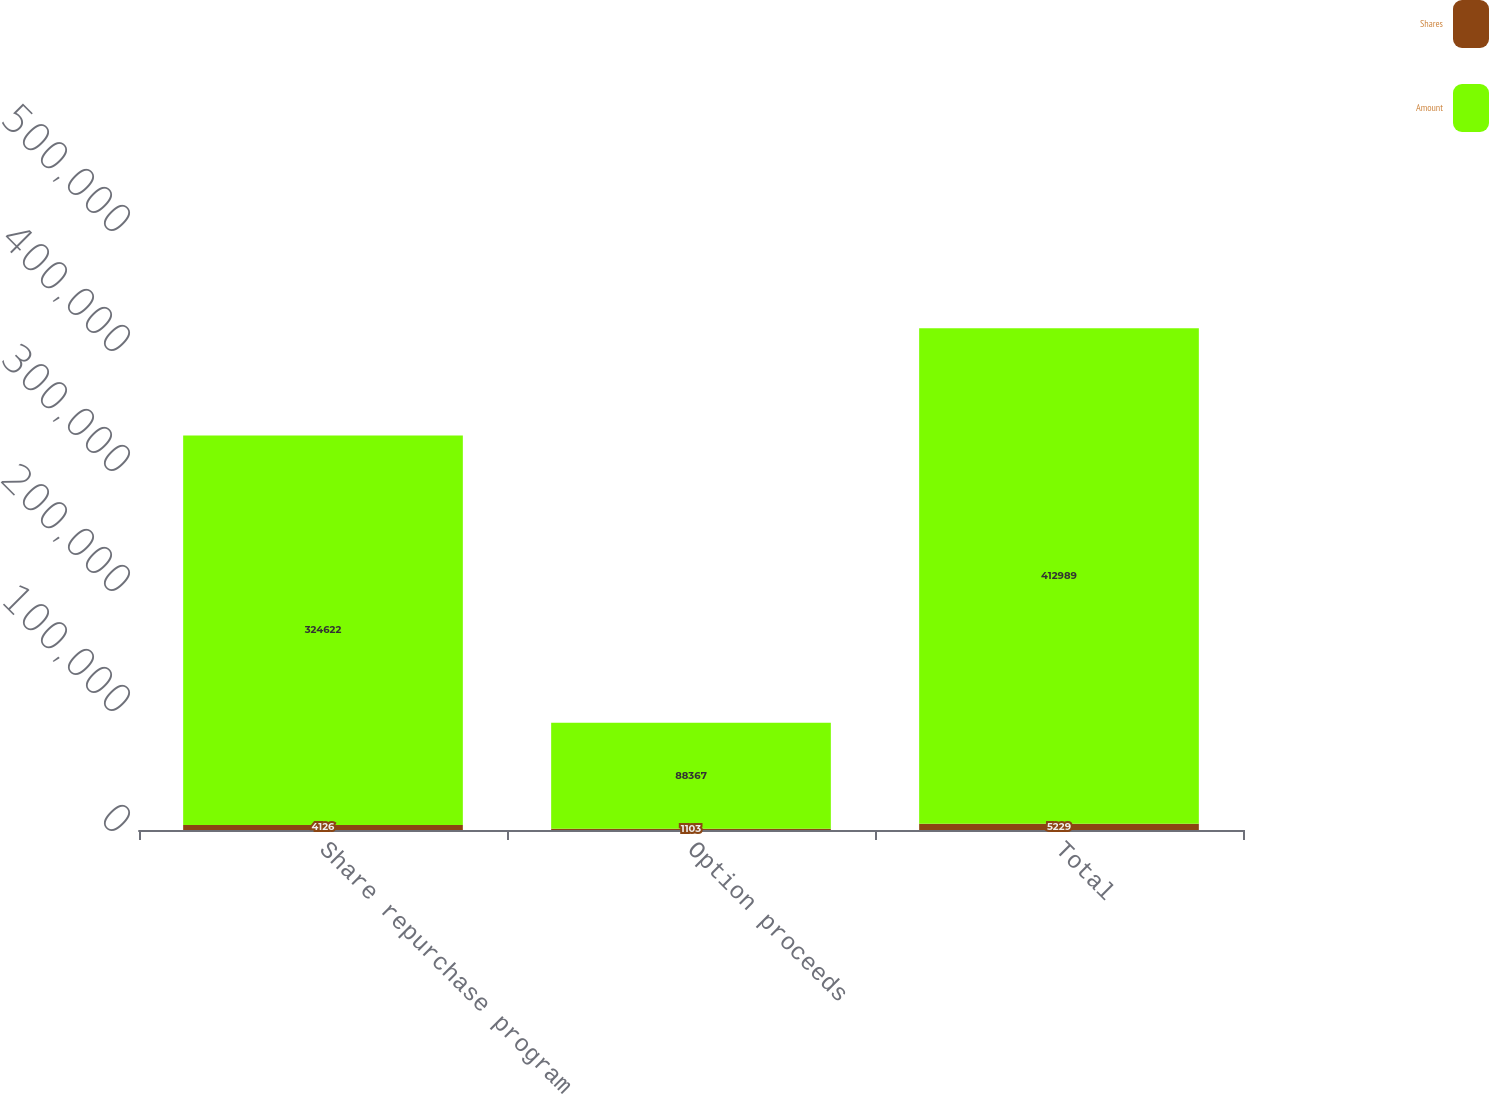Convert chart. <chart><loc_0><loc_0><loc_500><loc_500><stacked_bar_chart><ecel><fcel>Share repurchase program<fcel>Option proceeds<fcel>Total<nl><fcel>Shares<fcel>4126<fcel>1103<fcel>5229<nl><fcel>Amount<fcel>324622<fcel>88367<fcel>412989<nl></chart> 